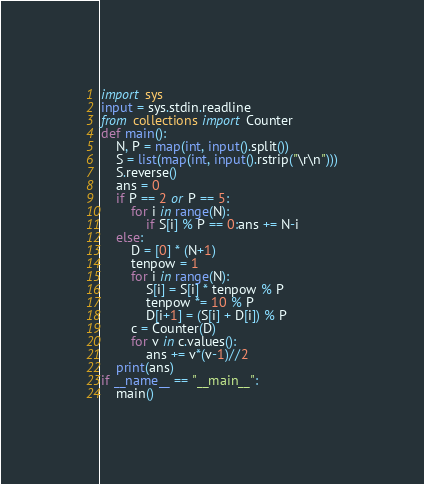<code> <loc_0><loc_0><loc_500><loc_500><_Python_>import sys
input = sys.stdin.readline
from collections import Counter
def main():
    N, P = map(int, input().split())
    S = list(map(int, input().rstrip("\r\n")))
    S.reverse()
    ans = 0
    if P == 2 or P == 5:
        for i in range(N):
            if S[i] % P == 0:ans += N-i
    else:
        D = [0] * (N+1)
        tenpow = 1
        for i in range(N):
            S[i] = S[i] * tenpow % P
            tenpow *= 10 % P
            D[i+1] = (S[i] + D[i]) % P
        c = Counter(D)
        for v in c.values():
            ans += v*(v-1)//2
    print(ans)
if __name__ == "__main__":
    main()</code> 